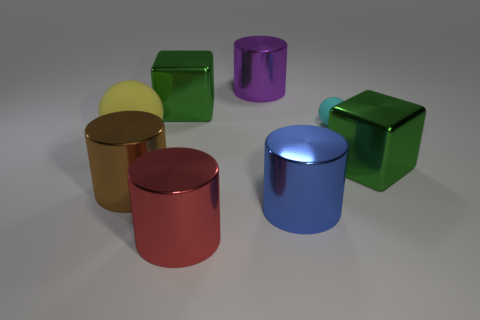Add 1 big shiny cubes. How many objects exist? 9 Subtract all blocks. How many objects are left? 6 Subtract 0 red balls. How many objects are left? 8 Subtract all cylinders. Subtract all big blue metal cylinders. How many objects are left? 3 Add 5 large yellow things. How many large yellow things are left? 6 Add 1 purple cylinders. How many purple cylinders exist? 2 